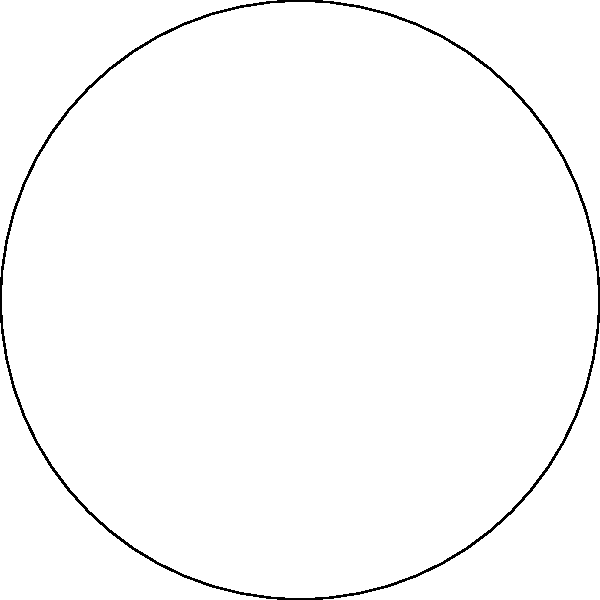Using the color-coded chakra diagram, match the following gemstones to their corresponding chakras:

1. Amethyst
2. Citrine
3. Rose Quartz
4. Lapis Lazuli
5. Red Jasper
6. Tiger's Eye
7. Clear Quartz

Provide your answer as a list of chakra names in the order of the gemstones listed above. To match the gemstones to their corresponding chakras, we need to consider the traditional color associations of both the chakras and the gemstones:

1. Amethyst is purple, corresponding to the Crown chakra.
2. Citrine is yellow, corresponding to the Solar Plexus chakra.
3. Rose Quartz is pink (a lighter shade of red), corresponding to the Heart chakra.
4. Lapis Lazuli is blue, corresponding to the Throat chakra.
5. Red Jasper is red, corresponding to the Root chakra.
6. Tiger's Eye is orange, corresponding to the Sacral chakra.
7. Clear Quartz is often associated with white or clear energy, corresponding to the Third Eye chakra.

By matching the colors of the gemstones to the colors in the chakra diagram, we can determine the correct associations.
Answer: Crown, Solar Plexus, Heart, Throat, Root, Sacral, Third Eye 